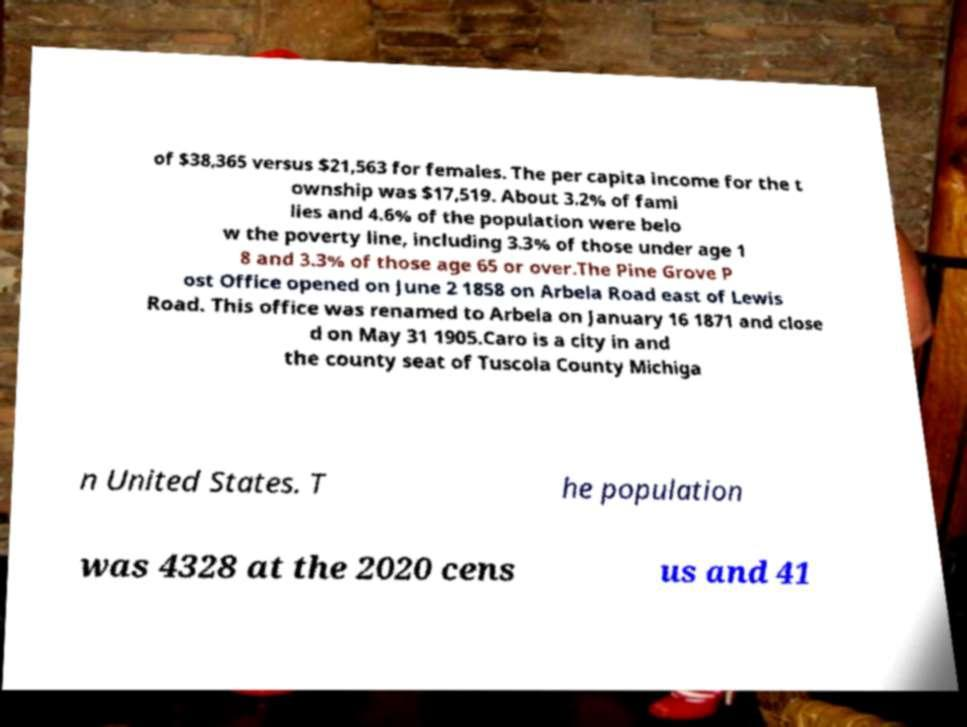For documentation purposes, I need the text within this image transcribed. Could you provide that? of $38,365 versus $21,563 for females. The per capita income for the t ownship was $17,519. About 3.2% of fami lies and 4.6% of the population were belo w the poverty line, including 3.3% of those under age 1 8 and 3.3% of those age 65 or over.The Pine Grove P ost Office opened on June 2 1858 on Arbela Road east of Lewis Road. This office was renamed to Arbela on January 16 1871 and close d on May 31 1905.Caro is a city in and the county seat of Tuscola County Michiga n United States. T he population was 4328 at the 2020 cens us and 41 